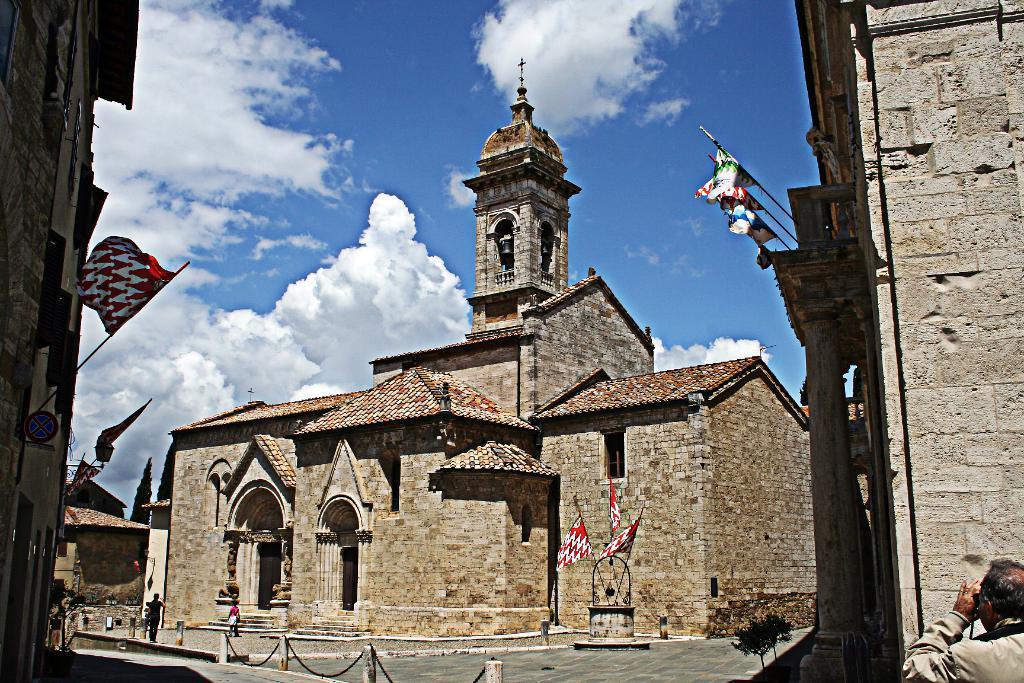How would you summarize this image in a sentence or two? There is a castle in the back with some flags in front of it and some people walking on the floor and above its sky with clouds. 